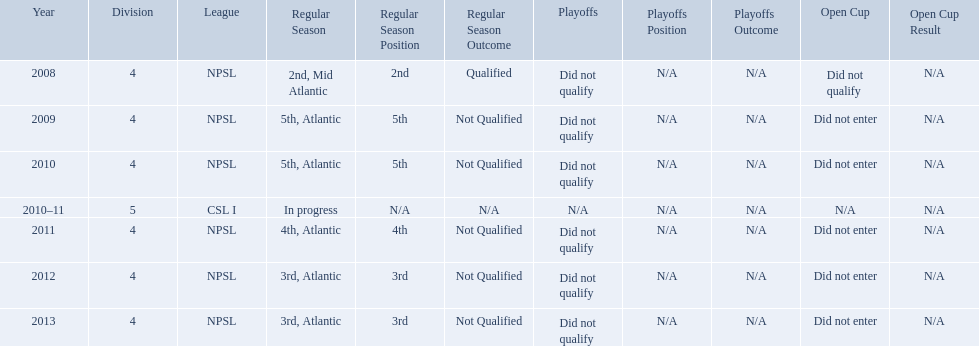What are the names of the leagues? NPSL, CSL I. Which league other than npsl did ny soccer team play under? CSL I. 